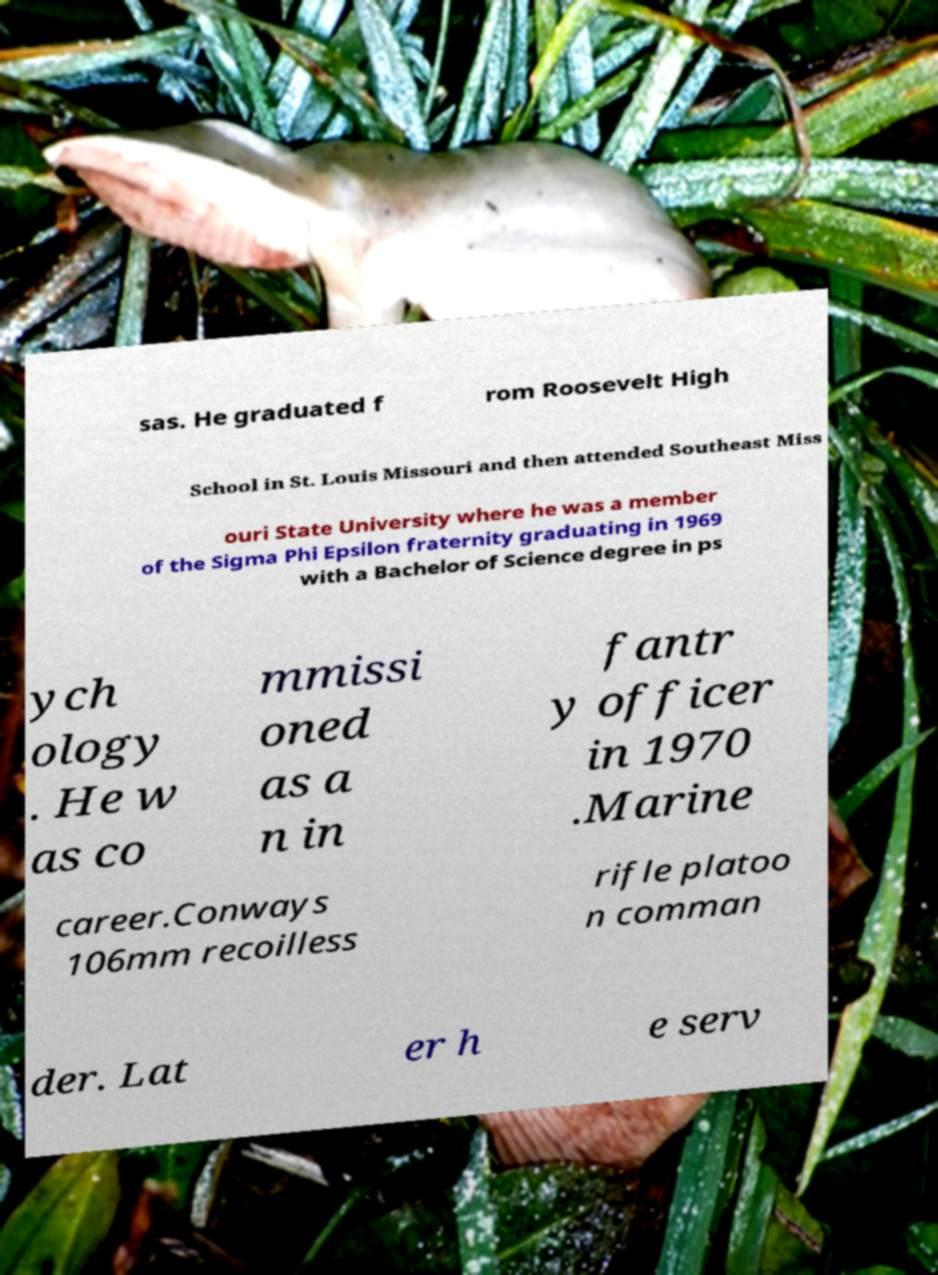Can you read and provide the text displayed in the image?This photo seems to have some interesting text. Can you extract and type it out for me? sas. He graduated f rom Roosevelt High School in St. Louis Missouri and then attended Southeast Miss ouri State University where he was a member of the Sigma Phi Epsilon fraternity graduating in 1969 with a Bachelor of Science degree in ps ych ology . He w as co mmissi oned as a n in fantr y officer in 1970 .Marine career.Conways 106mm recoilless rifle platoo n comman der. Lat er h e serv 